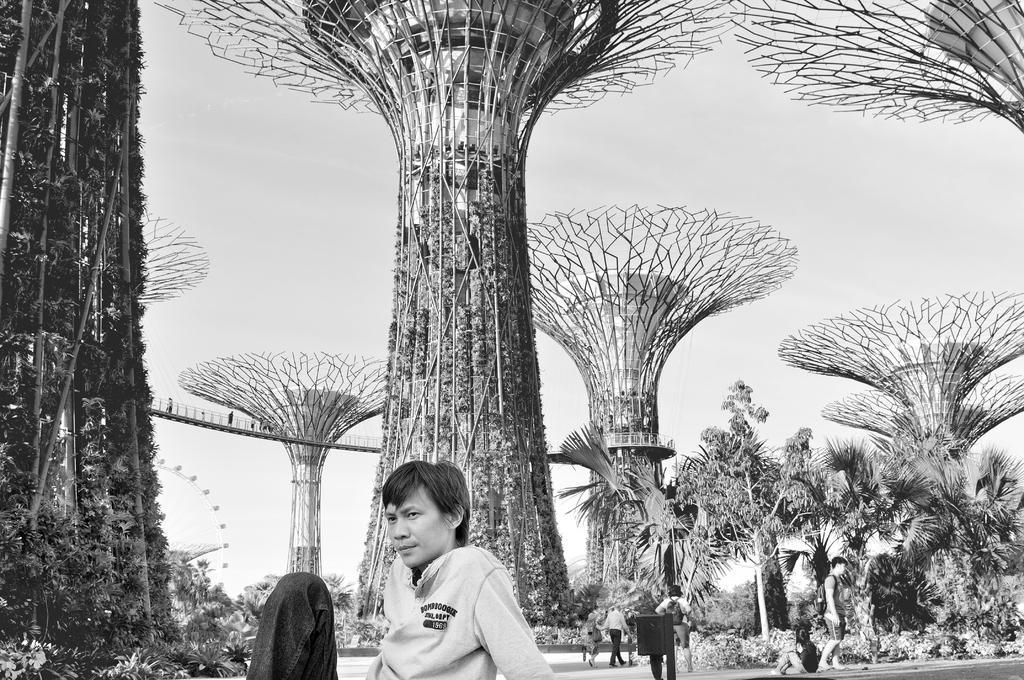Describe this image in one or two sentences. This is a black and white image. In this image we can see a person sitting on the ground and some are standing on the ground. In the background we can see trees, sky, plants and poles. 